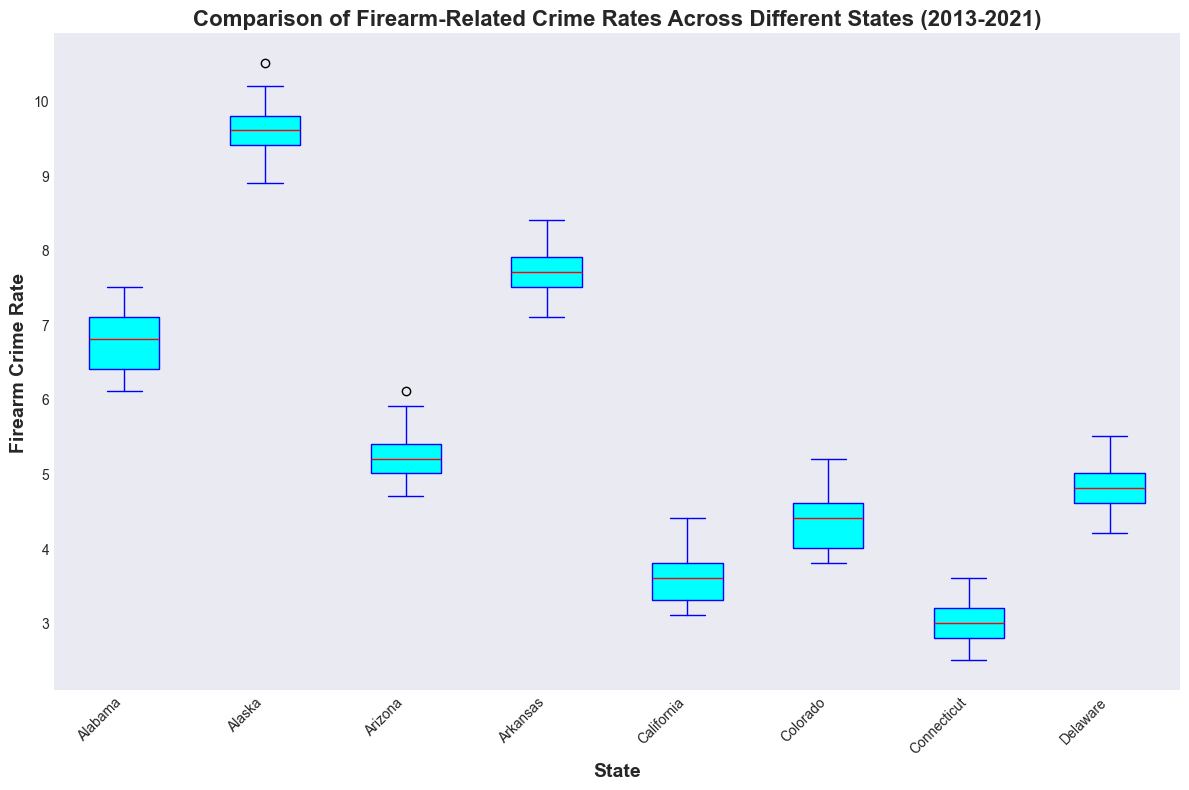Which state has the highest overall firearm-related crime rate? By looking at the medians indicated by the red lines in each box of the box plot, we can see that Alaska has the highest median firearm-related crime rate compared to other states.
Answer: Alaska Which state has the lowest median firearm-related crime rate? By observing the red median lines within the box plots, we notice that Connecticut has the lowest median firearm-related crime rate of all the states presented.
Answer: Connecticut Is the median firearm-related crime rate in Arkansas higher than in Alabama? By comparing the red median lines within the box plots for Arkansas and Alabama, it's clear that Arkansas's median is higher than Alabama's median.
Answer: Yes Which states have a similar range of firearm-related crime rates? States with similar box sizes and similar length of whiskers indicate a similar range. For example, Arkansas and Alaska show similar ranges of firearm-related crime rates.
Answer: Arkansas and Alaska Which state shows the greatest variability in firearm-related crime rates over the past decade? The state with the widest box and longest whiskers indicates the greatest variability. Alaska's box plot shows the widest range and whiskers, indicating the highest variability.
Answer: Alaska How does California's median firearm-related crime rate compare to Colorado's? The red median line in California’s box plot is lower than the corresponding red median line in Colorado’s box plot.
Answer: California’s is lower than Colorado’s Is there any state with an outlier in firearm-related crime rates? Outliers are usually depicted as points outside the whiskers of the box plot. There are no apparent points outside the whiskers in any state's box plot, indicating no outliers.
Answer: No From a visual perspective, how does the interquartile range (IQR) of Connecticut compare to that of Delaware? The interquartile range (IQR) is represented by the height of the box. Connecticut’s IQR is smaller than Delaware’s IQR, indicating a smaller range of middle 50% values in Connecticut compared to Delaware.
Answer: Connecticut’s IQR is smaller Which state shows the most consistent firearm-related crime rates over the years? The most consistent rates are indicated by the box plot with the smallest range and shortest whiskers. Connecticut shows the most consistency as it has the shortest box and whiskers.
Answer: Connecticut What can be inferred about firearm-related crime rates in Arizona and Colorado over the decade? By checking the positions and spans of the boxes for Arizona and Colorado, it's clear that both states have lower medians but Colorado's values range slightly wider than Arizona's, indicating higher variability.
Answer: Both have lower medians, but Colorado has more variability 